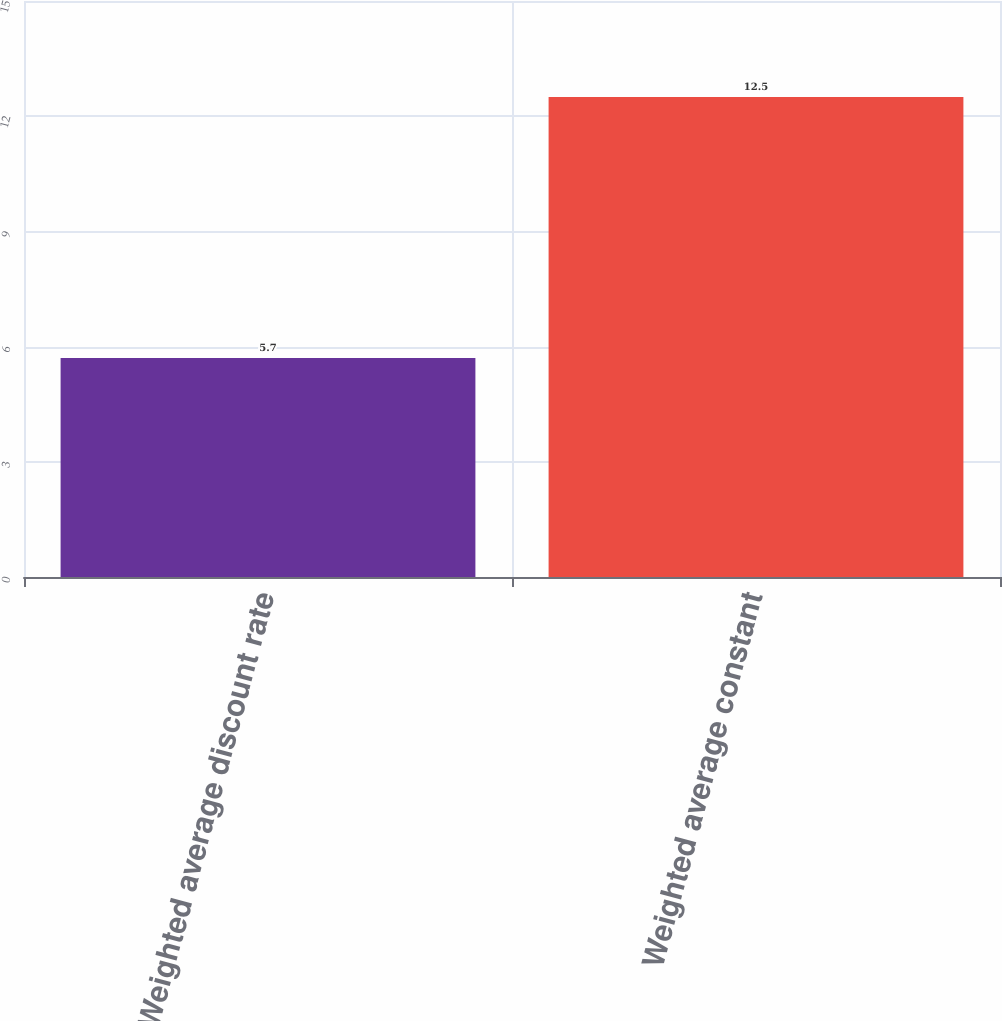Convert chart to OTSL. <chart><loc_0><loc_0><loc_500><loc_500><bar_chart><fcel>Weighted average discount rate<fcel>Weighted average constant<nl><fcel>5.7<fcel>12.5<nl></chart> 